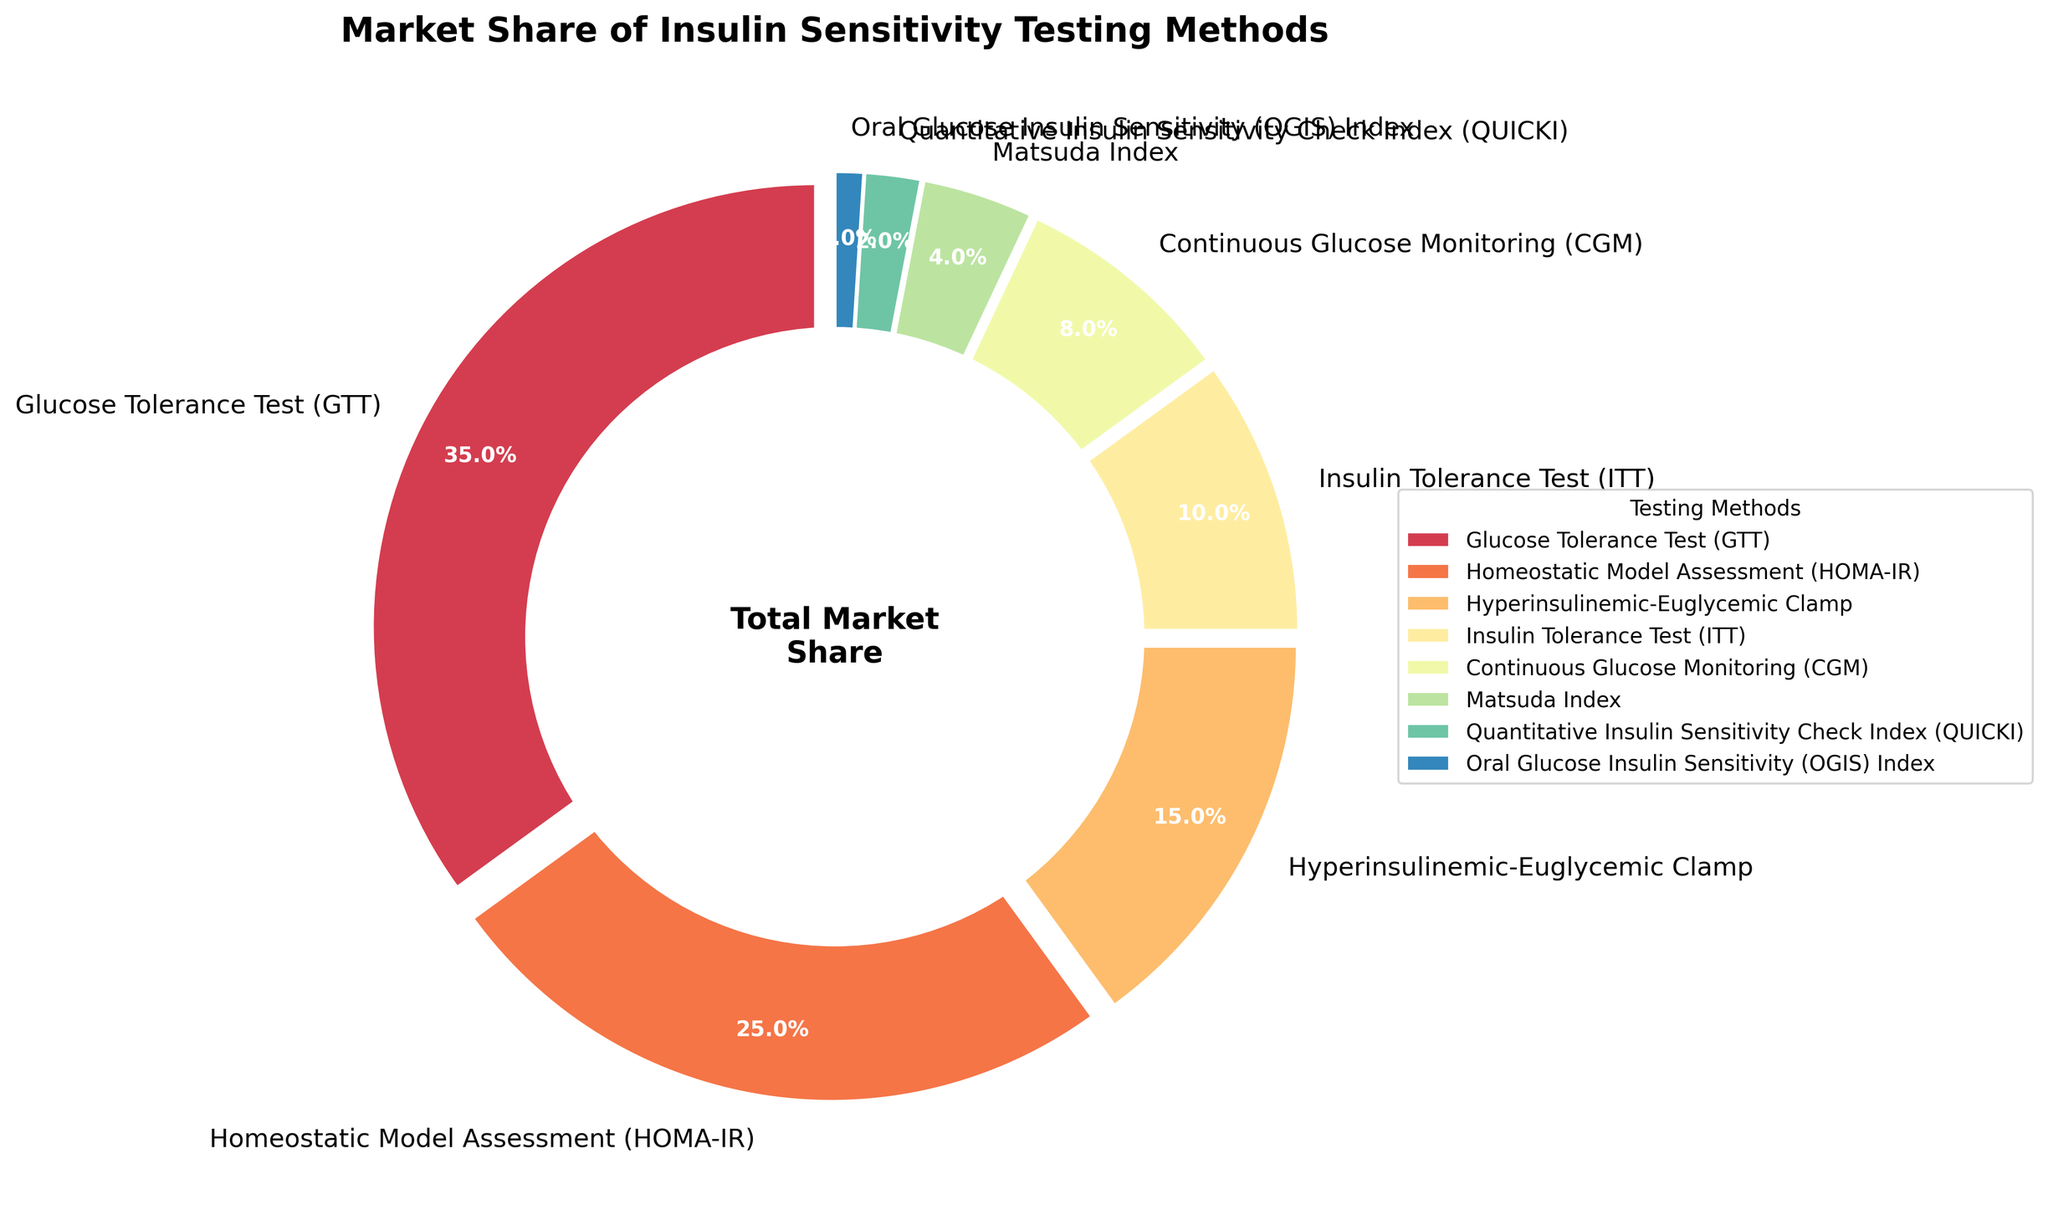Which testing method has the highest market share? The pie chart shows that the Glucose Tolerance Test (GTT) segment is the largest among the wedges and is labeled with the highest percentage.
Answer: Glucose Tolerance Test (GTT) What is the combined market share of the Homeostatic Model Assessment (HOMA-IR) and the Insulin Tolerance Test (ITT)? The chart shows HOMA-IR with a market share of 25% and ITT with 10%. Adding these percentages together gives 25% + 10% = 35%.
Answer: 35% Which testing methods have a market share less than 5%? The pie chart segments labeled with market shares less than 5% are the Matsuda Index (4%), Quantitative Insulin Sensitivity Check Index (QUICKI) (2%), and Oral Glucose Insulin Sensitivity (OGIS) Index (1%).
Answer: Matsuda Index, QUICKI, and OGIS Index How much larger is the market share of the Hyperinsulinemic-Euglycemic Clamp compared to the Continuous Glucose Monitoring? The Hyperinsulinemic-Euglycemic Clamp has 15% and CGM has 8%. The difference in their market shares is 15% - 8% = 7%.
Answer: 7% What percentage of the market share is covered by methods with 10% or more market share? Methods with 10% or more market share are GTT (35%), HOMA-IR (25%), and Hyperinsulinemic-Euglycemic Clamp (15%). Their combined share is 35% + 25% + 15% = 75%.
Answer: 75% Which segment appears closest to the 90-degree start angle of the pie chart? The pie chart starts at 90 degrees, with the largest segment, Glucose Tolerance Test (GTT), beginning at this point.
Answer: Glucose Tolerance Test (GTT) What is the difference in market share between the Continuous Glucose Monitoring (CGM) and the Matsuda Index? The market shares are 8% for CGM and 4% for Matsuda Index. The difference is 8% - 4% = 4%.
Answer: 4% Rank the top three testing methods by market share. The pie chart indicates the following market shares: GTT (35%), HOMA-IR (25%), and Hyperinsulinemic-Euglycemic Clamp (15%). Ranking them from highest to lowest gives: 1. GTT 2. HOMA-IR 3. Hyperinsulinemic-Euglycemic Clamp.
Answer: GTT, HOMA-IR, Hyperinsulinemic-Euglycemic Clamp Identify the two segments that have the smallest market shares. The smallest market shares are labeled as 1% for OGIS Index and 2% for QUICKI.
Answer: OGIS Index and QUICKI 